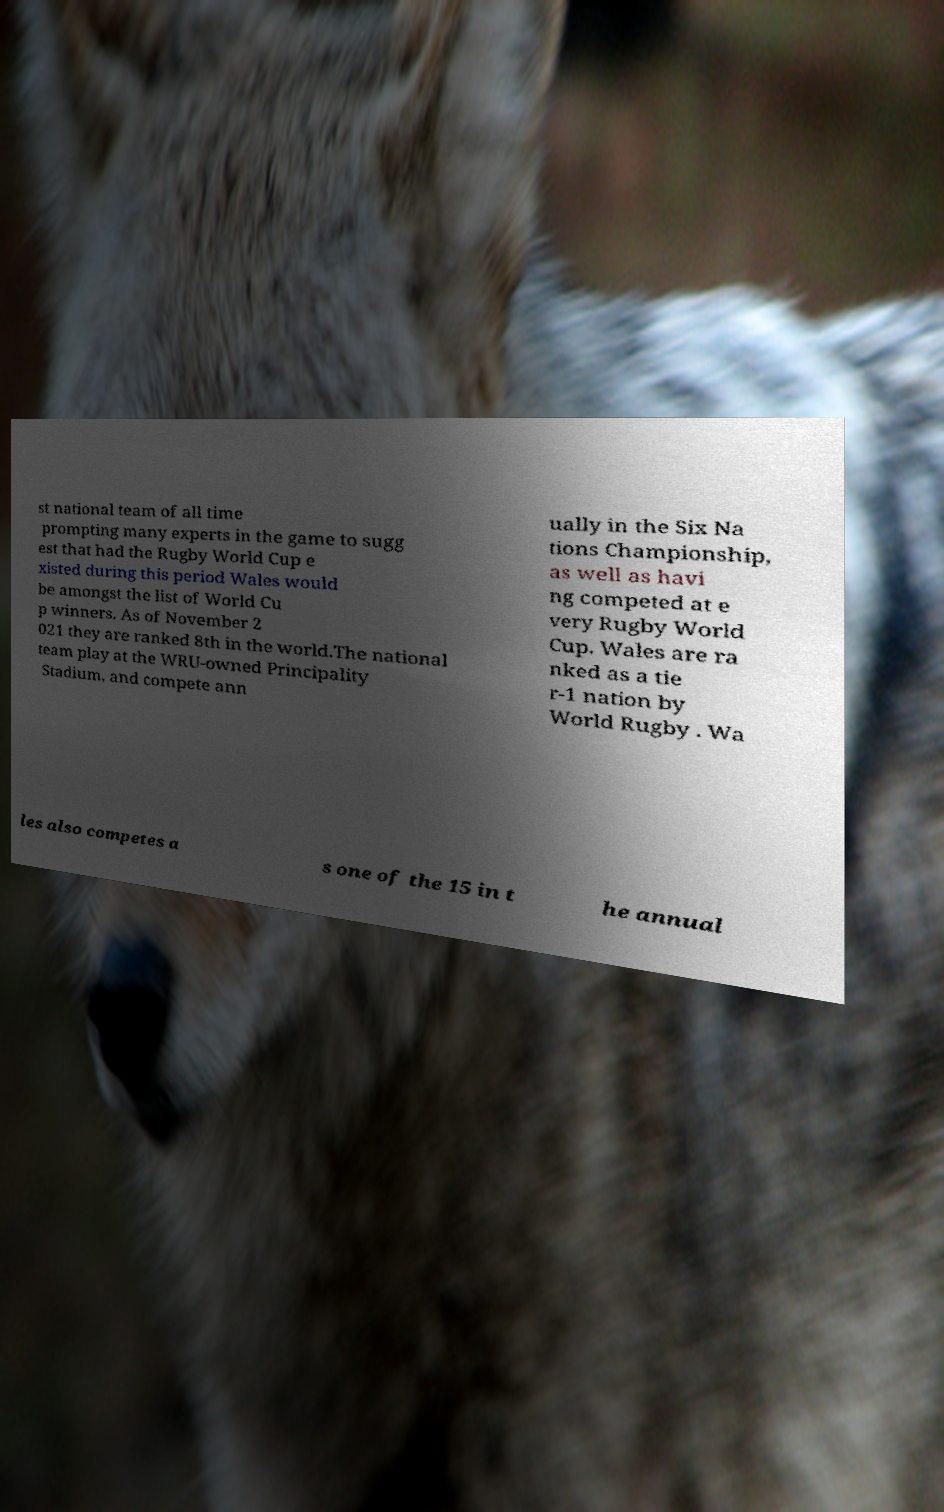Can you read and provide the text displayed in the image?This photo seems to have some interesting text. Can you extract and type it out for me? st national team of all time prompting many experts in the game to sugg est that had the Rugby World Cup e xisted during this period Wales would be amongst the list of World Cu p winners. As of November 2 021 they are ranked 8th in the world.The national team play at the WRU-owned Principality Stadium, and compete ann ually in the Six Na tions Championship, as well as havi ng competed at e very Rugby World Cup. Wales are ra nked as a tie r-1 nation by World Rugby . Wa les also competes a s one of the 15 in t he annual 